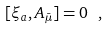Convert formula to latex. <formula><loc_0><loc_0><loc_500><loc_500>[ \xi _ { a } , A _ { \bar { \mu } } ] = 0 \ ,</formula> 